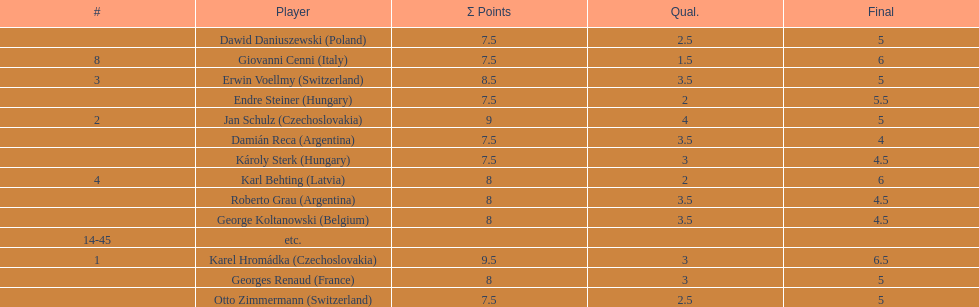How many players tied for 4th place? 4. 